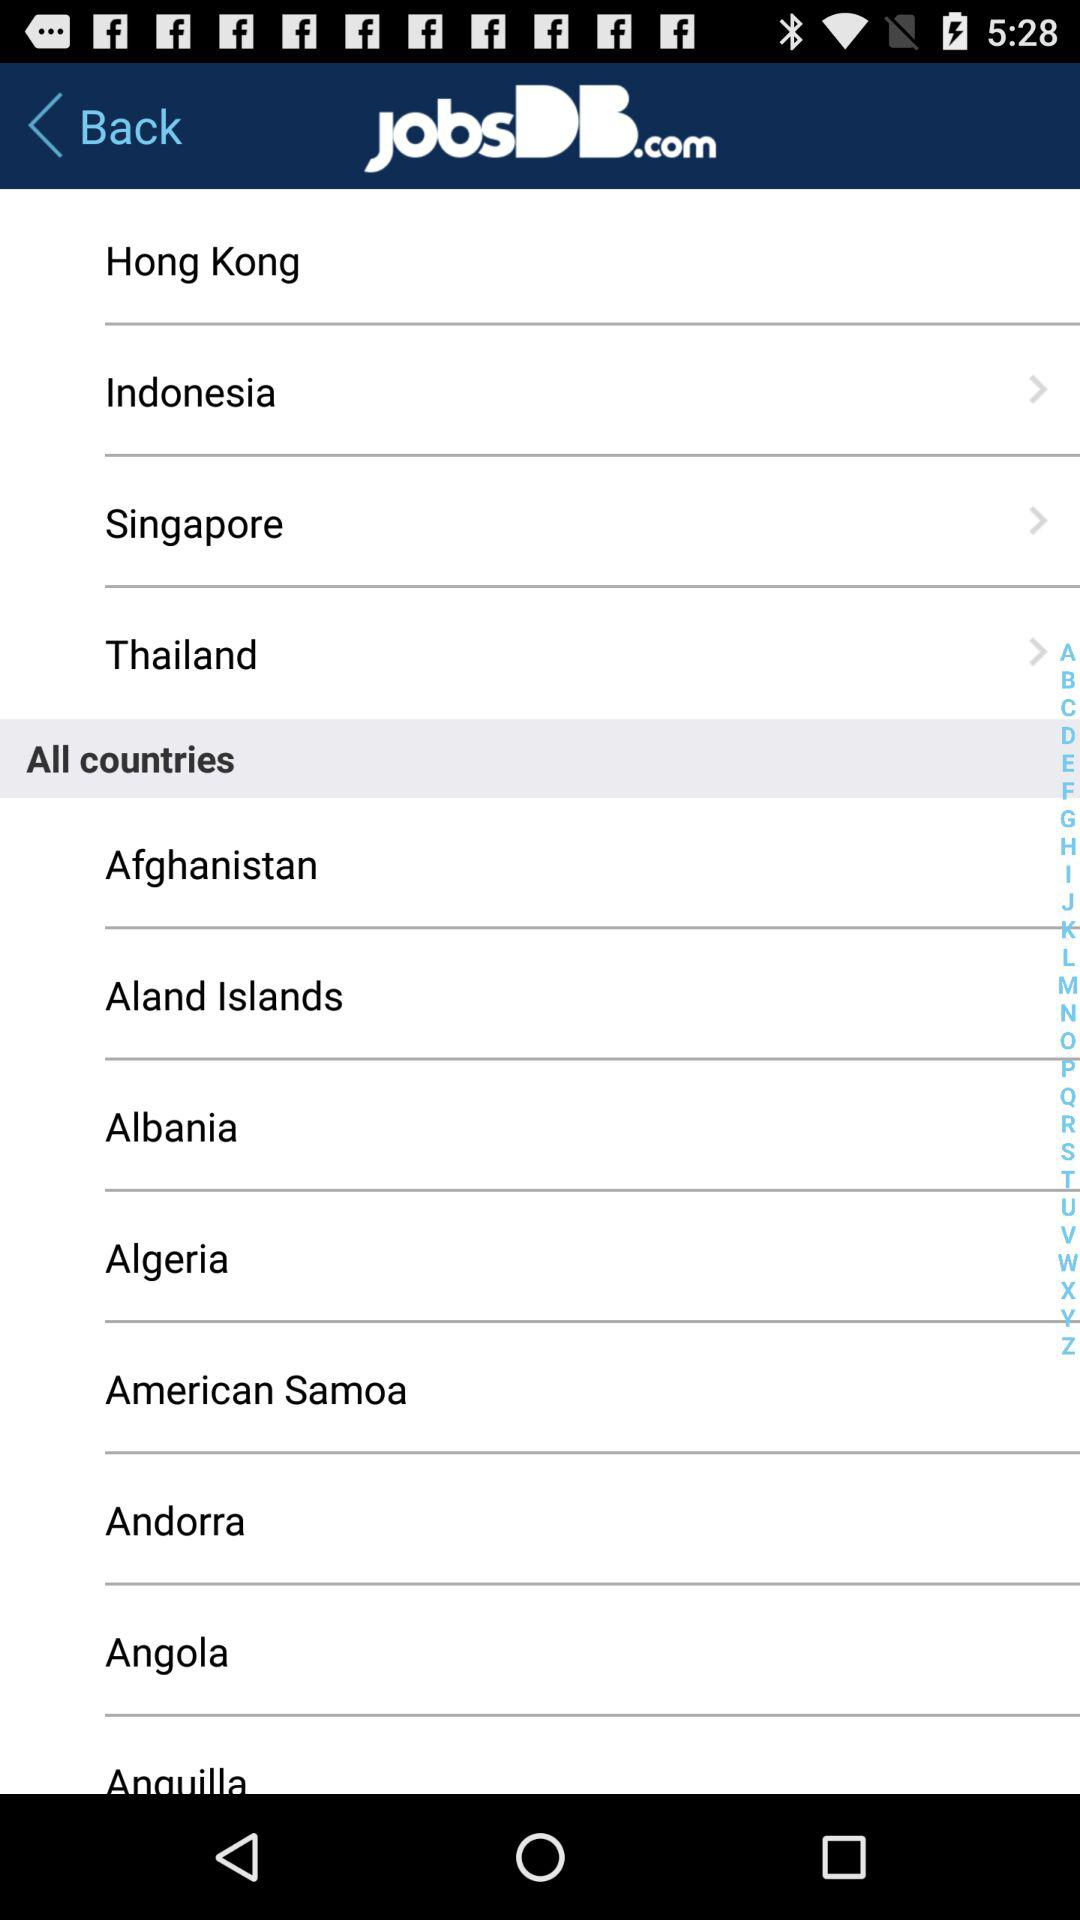What is the application name? The application name is "JobsDB.com". 